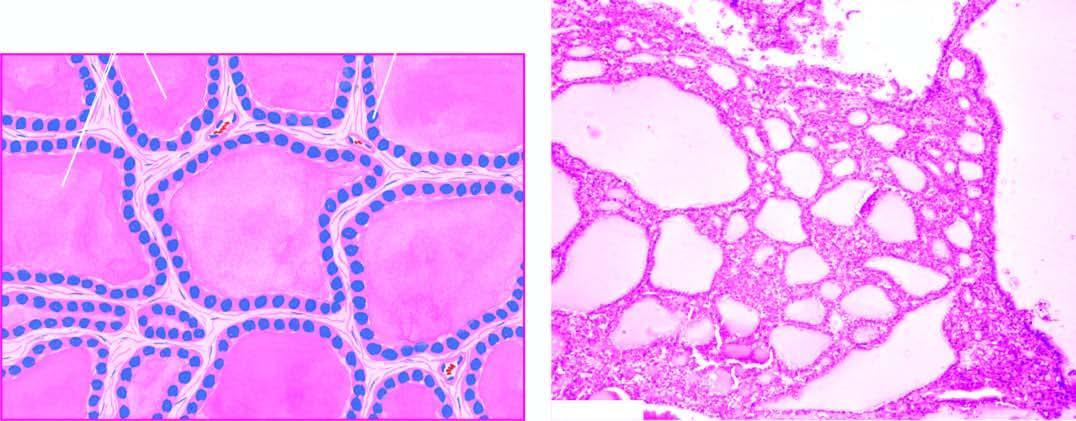what does microscopy show?
Answer the question using a single word or phrase. Large follicles distended by colloid and lined by flattened follicular epithelium 